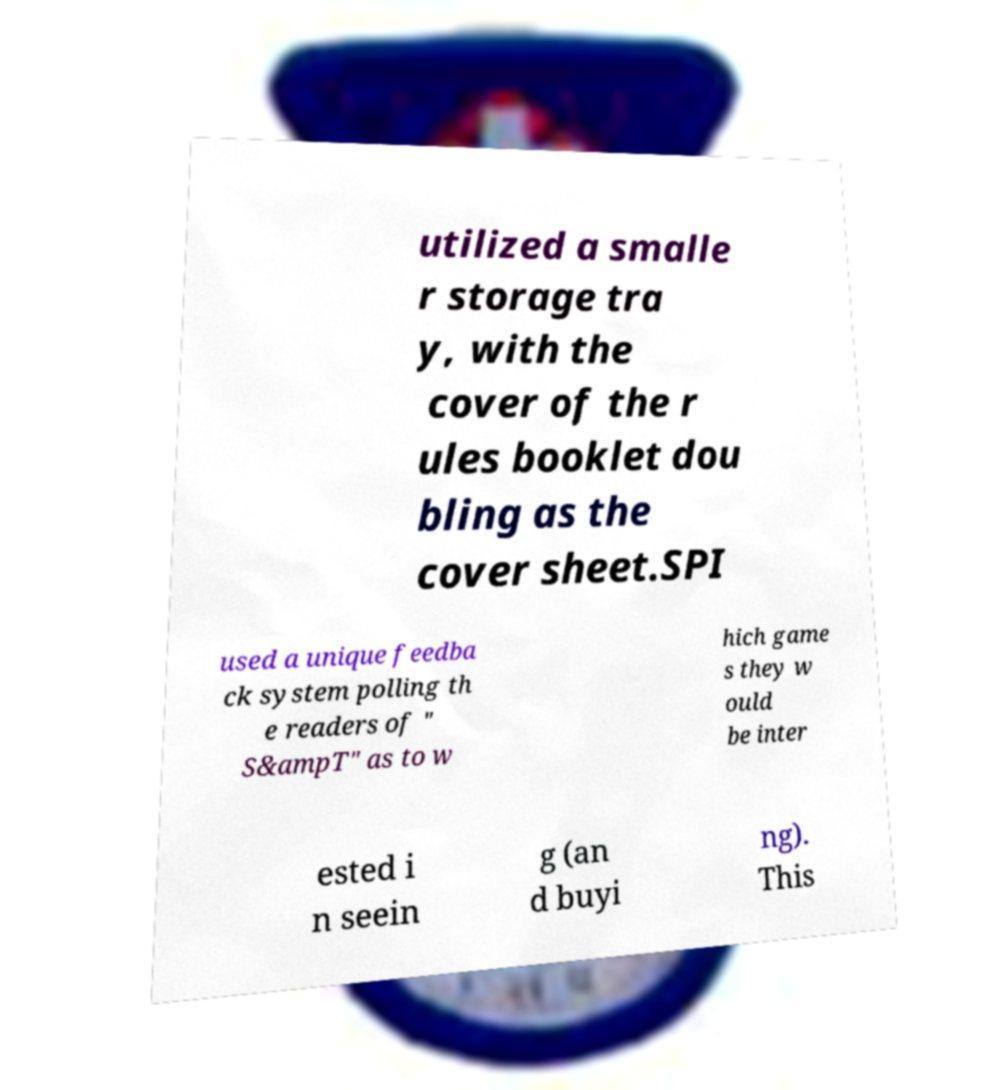Please read and relay the text visible in this image. What does it say? utilized a smalle r storage tra y, with the cover of the r ules booklet dou bling as the cover sheet.SPI used a unique feedba ck system polling th e readers of " S&ampT" as to w hich game s they w ould be inter ested i n seein g (an d buyi ng). This 